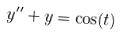<formula> <loc_0><loc_0><loc_500><loc_500>y ^ { \prime \prime } + y = \cos ( t )</formula> 